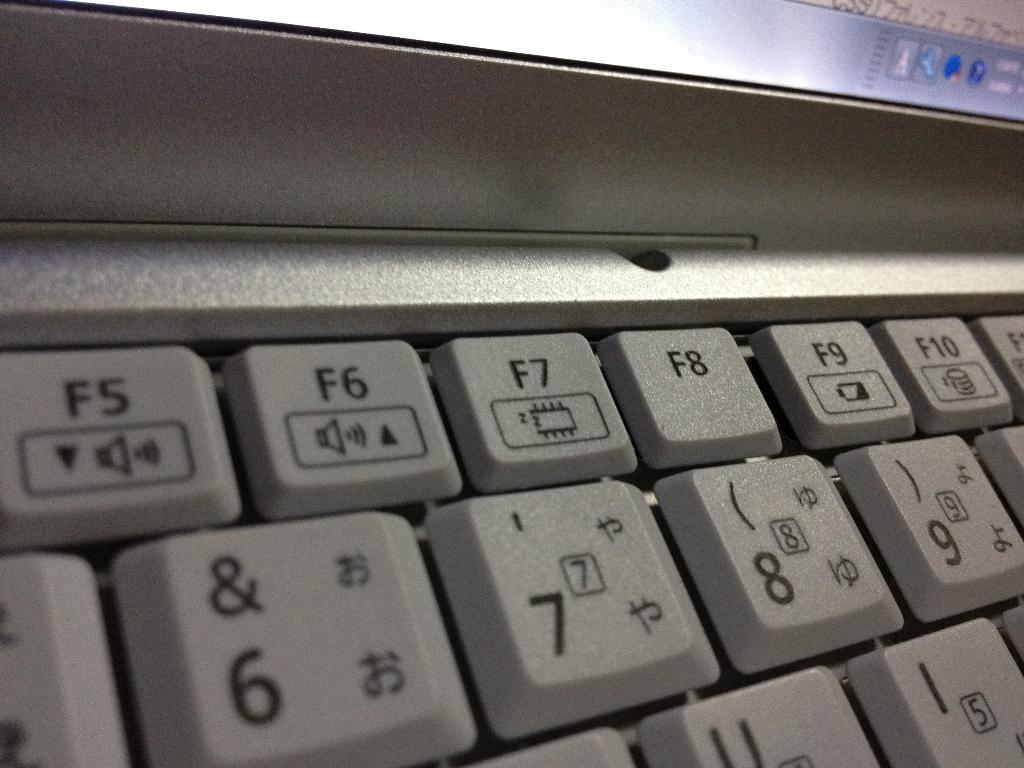What object in the image has buttons? There are buttons on a keyboard in the image. Are the buttons on the keyboard visible? Yes, the buttons on the keyboard are visible. How many plants are sitting on the chairs in the image? There are no plants or chairs present in the image; it only features a keyboard with visible buttons. 